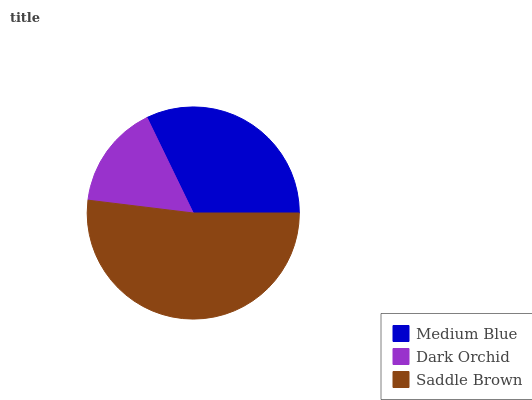Is Dark Orchid the minimum?
Answer yes or no. Yes. Is Saddle Brown the maximum?
Answer yes or no. Yes. Is Saddle Brown the minimum?
Answer yes or no. No. Is Dark Orchid the maximum?
Answer yes or no. No. Is Saddle Brown greater than Dark Orchid?
Answer yes or no. Yes. Is Dark Orchid less than Saddle Brown?
Answer yes or no. Yes. Is Dark Orchid greater than Saddle Brown?
Answer yes or no. No. Is Saddle Brown less than Dark Orchid?
Answer yes or no. No. Is Medium Blue the high median?
Answer yes or no. Yes. Is Medium Blue the low median?
Answer yes or no. Yes. Is Dark Orchid the high median?
Answer yes or no. No. Is Dark Orchid the low median?
Answer yes or no. No. 